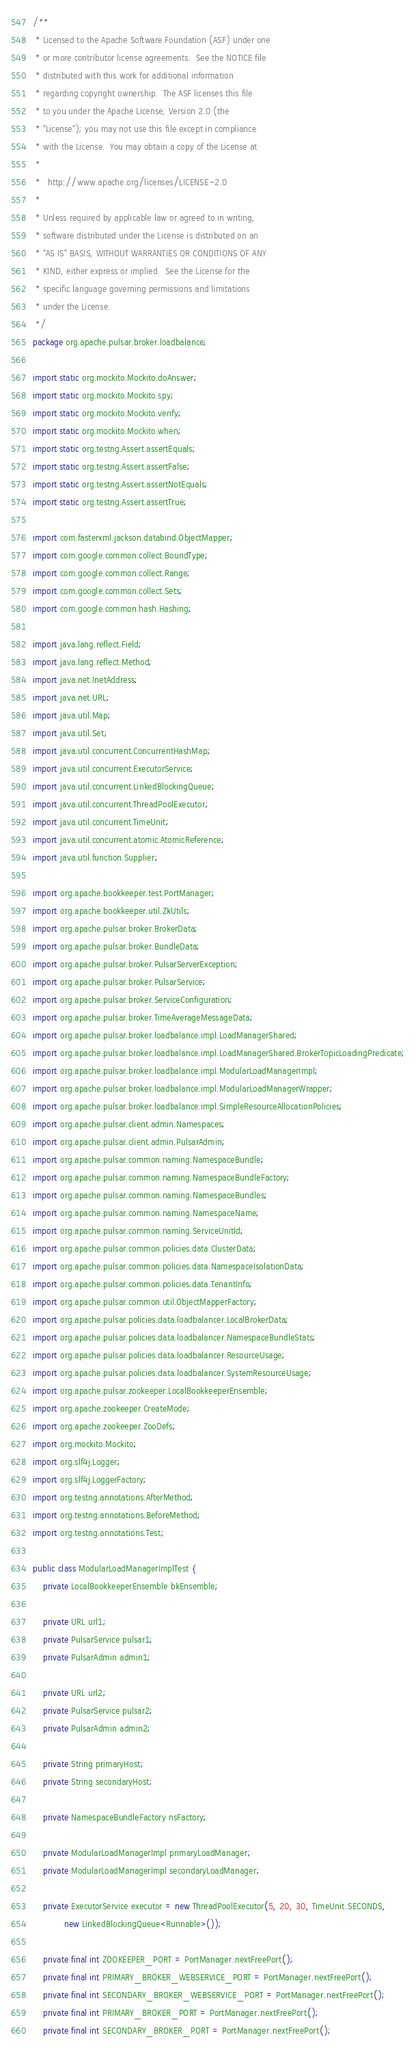Convert code to text. <code><loc_0><loc_0><loc_500><loc_500><_Java_>/**
 * Licensed to the Apache Software Foundation (ASF) under one
 * or more contributor license agreements.  See the NOTICE file
 * distributed with this work for additional information
 * regarding copyright ownership.  The ASF licenses this file
 * to you under the Apache License, Version 2.0 (the
 * "License"); you may not use this file except in compliance
 * with the License.  You may obtain a copy of the License at
 *
 *   http://www.apache.org/licenses/LICENSE-2.0
 *
 * Unless required by applicable law or agreed to in writing,
 * software distributed under the License is distributed on an
 * "AS IS" BASIS, WITHOUT WARRANTIES OR CONDITIONS OF ANY
 * KIND, either express or implied.  See the License for the
 * specific language governing permissions and limitations
 * under the License.
 */
package org.apache.pulsar.broker.loadbalance;

import static org.mockito.Mockito.doAnswer;
import static org.mockito.Mockito.spy;
import static org.mockito.Mockito.verify;
import static org.mockito.Mockito.when;
import static org.testng.Assert.assertEquals;
import static org.testng.Assert.assertFalse;
import static org.testng.Assert.assertNotEquals;
import static org.testng.Assert.assertTrue;

import com.fasterxml.jackson.databind.ObjectMapper;
import com.google.common.collect.BoundType;
import com.google.common.collect.Range;
import com.google.common.collect.Sets;
import com.google.common.hash.Hashing;

import java.lang.reflect.Field;
import java.lang.reflect.Method;
import java.net.InetAddress;
import java.net.URL;
import java.util.Map;
import java.util.Set;
import java.util.concurrent.ConcurrentHashMap;
import java.util.concurrent.ExecutorService;
import java.util.concurrent.LinkedBlockingQueue;
import java.util.concurrent.ThreadPoolExecutor;
import java.util.concurrent.TimeUnit;
import java.util.concurrent.atomic.AtomicReference;
import java.util.function.Supplier;

import org.apache.bookkeeper.test.PortManager;
import org.apache.bookkeeper.util.ZkUtils;
import org.apache.pulsar.broker.BrokerData;
import org.apache.pulsar.broker.BundleData;
import org.apache.pulsar.broker.PulsarServerException;
import org.apache.pulsar.broker.PulsarService;
import org.apache.pulsar.broker.ServiceConfiguration;
import org.apache.pulsar.broker.TimeAverageMessageData;
import org.apache.pulsar.broker.loadbalance.impl.LoadManagerShared;
import org.apache.pulsar.broker.loadbalance.impl.LoadManagerShared.BrokerTopicLoadingPredicate;
import org.apache.pulsar.broker.loadbalance.impl.ModularLoadManagerImpl;
import org.apache.pulsar.broker.loadbalance.impl.ModularLoadManagerWrapper;
import org.apache.pulsar.broker.loadbalance.impl.SimpleResourceAllocationPolicies;
import org.apache.pulsar.client.admin.Namespaces;
import org.apache.pulsar.client.admin.PulsarAdmin;
import org.apache.pulsar.common.naming.NamespaceBundle;
import org.apache.pulsar.common.naming.NamespaceBundleFactory;
import org.apache.pulsar.common.naming.NamespaceBundles;
import org.apache.pulsar.common.naming.NamespaceName;
import org.apache.pulsar.common.naming.ServiceUnitId;
import org.apache.pulsar.common.policies.data.ClusterData;
import org.apache.pulsar.common.policies.data.NamespaceIsolationData;
import org.apache.pulsar.common.policies.data.TenantInfo;
import org.apache.pulsar.common.util.ObjectMapperFactory;
import org.apache.pulsar.policies.data.loadbalancer.LocalBrokerData;
import org.apache.pulsar.policies.data.loadbalancer.NamespaceBundleStats;
import org.apache.pulsar.policies.data.loadbalancer.ResourceUsage;
import org.apache.pulsar.policies.data.loadbalancer.SystemResourceUsage;
import org.apache.pulsar.zookeeper.LocalBookkeeperEnsemble;
import org.apache.zookeeper.CreateMode;
import org.apache.zookeeper.ZooDefs;
import org.mockito.Mockito;
import org.slf4j.Logger;
import org.slf4j.LoggerFactory;
import org.testng.annotations.AfterMethod;
import org.testng.annotations.BeforeMethod;
import org.testng.annotations.Test;

public class ModularLoadManagerImplTest {
    private LocalBookkeeperEnsemble bkEnsemble;

    private URL url1;
    private PulsarService pulsar1;
    private PulsarAdmin admin1;

    private URL url2;
    private PulsarService pulsar2;
    private PulsarAdmin admin2;

    private String primaryHost;
    private String secondaryHost;

    private NamespaceBundleFactory nsFactory;

    private ModularLoadManagerImpl primaryLoadManager;
    private ModularLoadManagerImpl secondaryLoadManager;

    private ExecutorService executor = new ThreadPoolExecutor(5, 20, 30, TimeUnit.SECONDS,
            new LinkedBlockingQueue<Runnable>());

    private final int ZOOKEEPER_PORT = PortManager.nextFreePort();
    private final int PRIMARY_BROKER_WEBSERVICE_PORT = PortManager.nextFreePort();
    private final int SECONDARY_BROKER_WEBSERVICE_PORT = PortManager.nextFreePort();
    private final int PRIMARY_BROKER_PORT = PortManager.nextFreePort();
    private final int SECONDARY_BROKER_PORT = PortManager.nextFreePort();</code> 